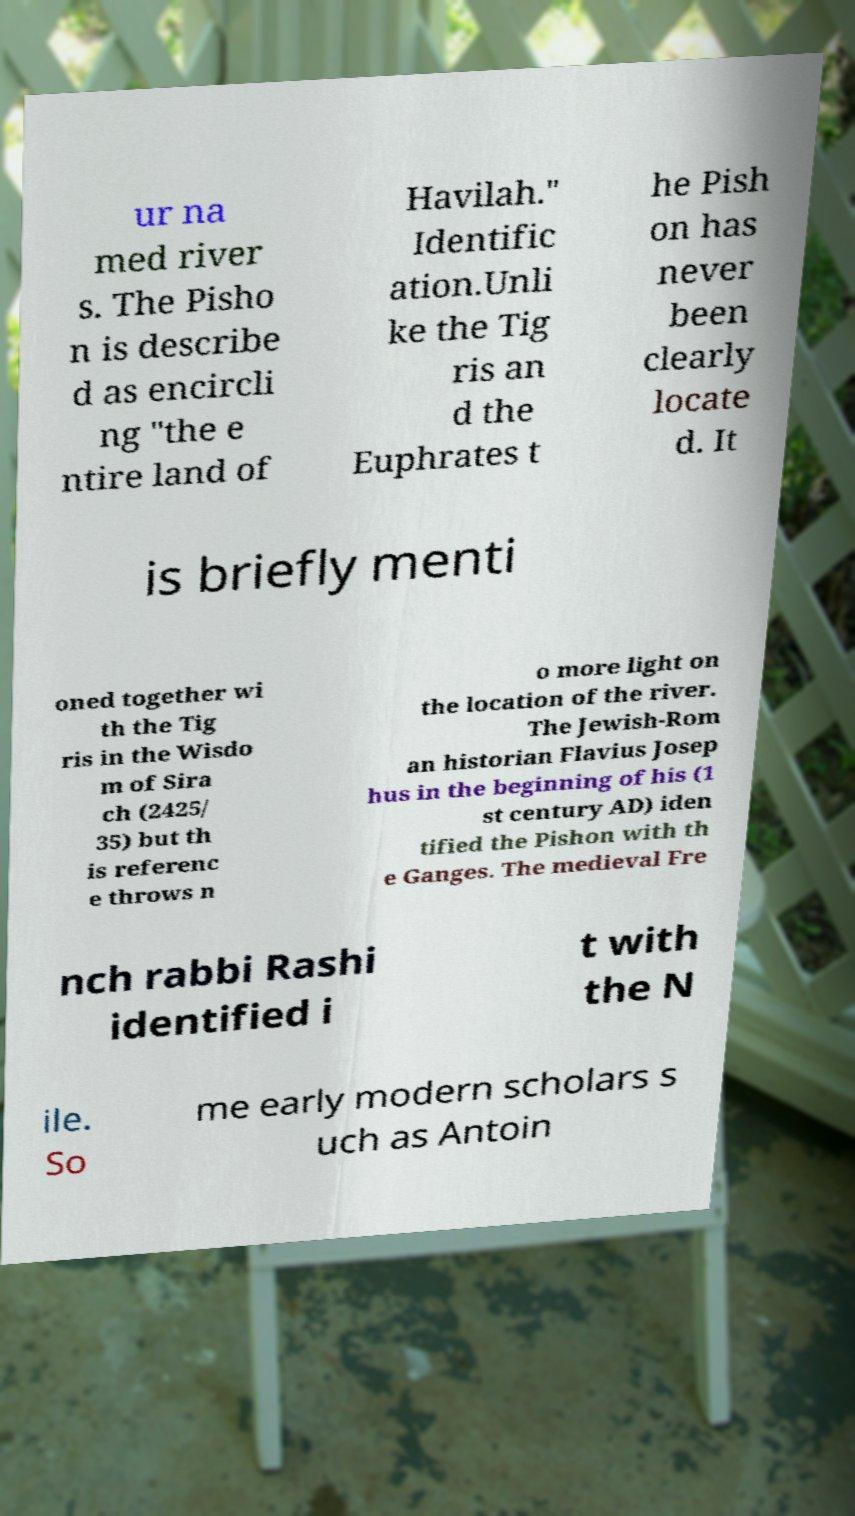Can you accurately transcribe the text from the provided image for me? ur na med river s. The Pisho n is describe d as encircli ng "the e ntire land of Havilah." Identific ation.Unli ke the Tig ris an d the Euphrates t he Pish on has never been clearly locate d. It is briefly menti oned together wi th the Tig ris in the Wisdo m of Sira ch (2425/ 35) but th is referenc e throws n o more light on the location of the river. The Jewish-Rom an historian Flavius Josep hus in the beginning of his (1 st century AD) iden tified the Pishon with th e Ganges. The medieval Fre nch rabbi Rashi identified i t with the N ile. So me early modern scholars s uch as Antoin 